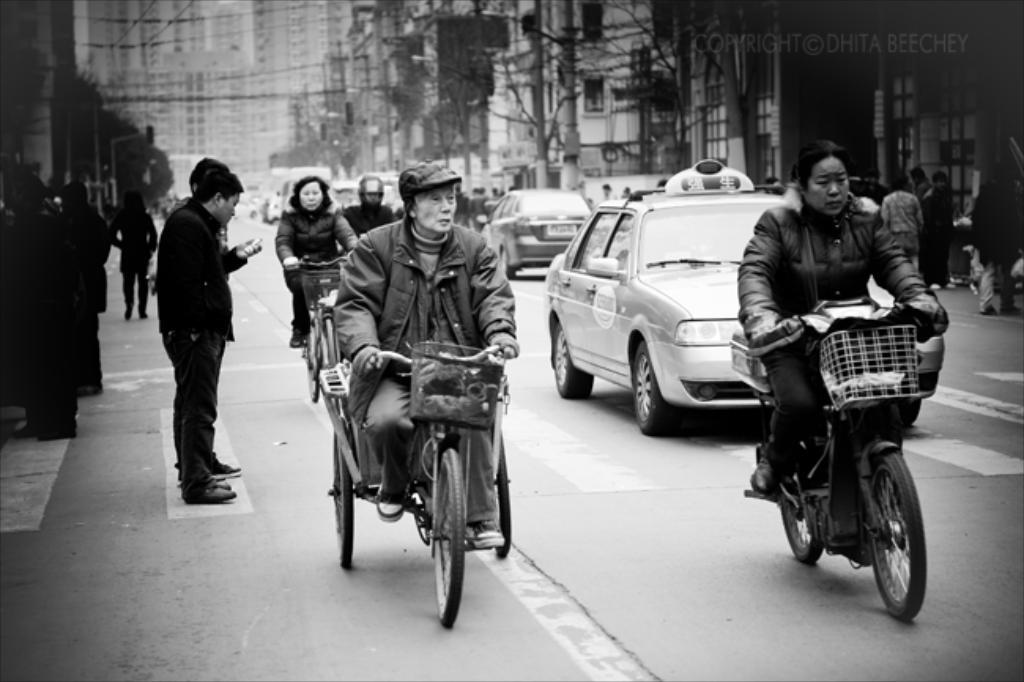What are the people in the image doing? The people in the image are riding vehicles. What type of surface are the vehicles on? The vehicles are on roads. Where are the roads located in relation to the buildings? The roads are behind the buildings. Can you see any wounds on the goat in the image? There is no goat present in the image, so it is not possible to see any wounds. What direction is the zephyr blowing in the image? There is no mention of a zephyr or any wind in the image, so it is not possible to determine its direction. 